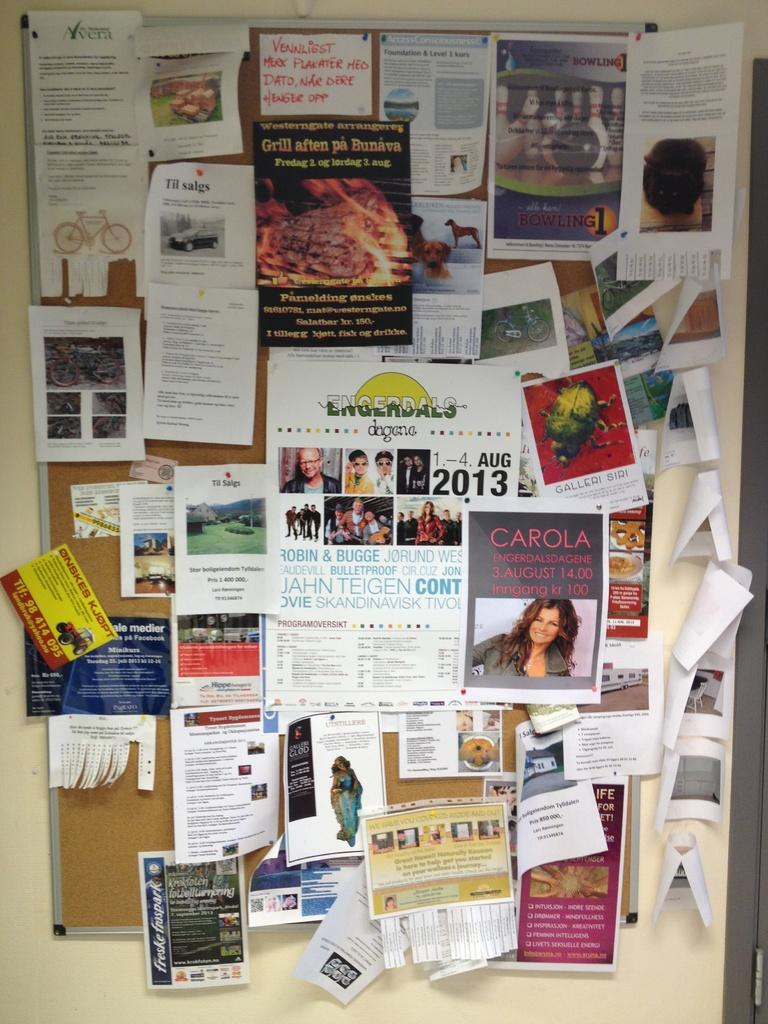<image>
Relay a brief, clear account of the picture shown. A bulletin board full of flyers has one that says Aug 2013 on it. 